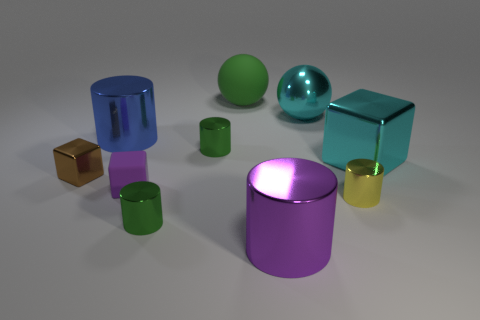What number of small cylinders are there? There are three small cylinders visible in the image, each with distinct colors - one is green, another yellow, and the last one purple, providing a colorful variety to the composition. 